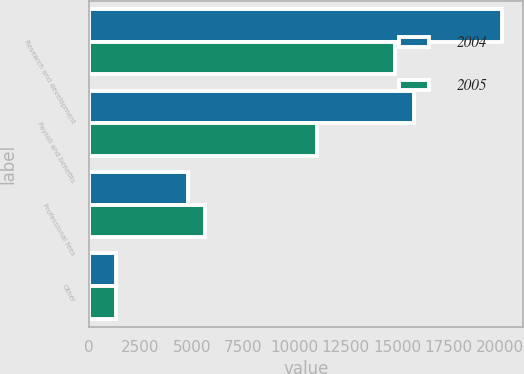Convert chart to OTSL. <chart><loc_0><loc_0><loc_500><loc_500><stacked_bar_chart><ecel><fcel>Research and development<fcel>Payroll and benefits<fcel>Professional fees<fcel>Other<nl><fcel>2004<fcel>20098<fcel>15832<fcel>4816<fcel>1315<nl><fcel>2005<fcel>14883<fcel>11114<fcel>5658<fcel>1296<nl></chart> 